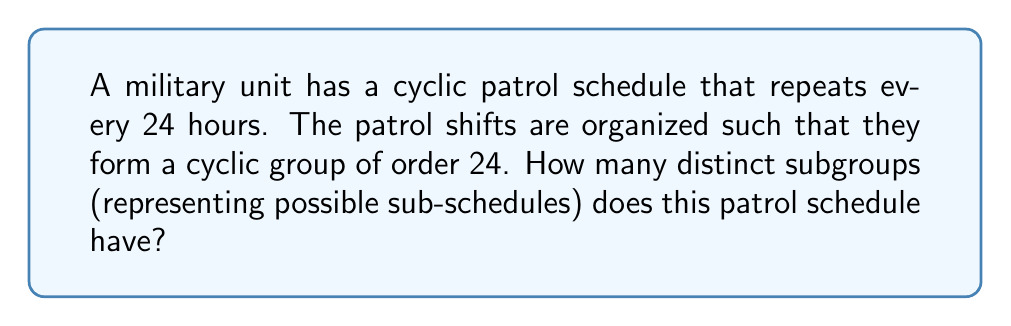Give your solution to this math problem. To solve this problem, we need to understand the structure of cyclic groups and their subgroups. Let's approach this step-by-step:

1) A cyclic group of order 24 is isomorphic to $\mathbb{Z}_{24}$, the group of integers modulo 24.

2) In a cyclic group, the number of subgroups is equal to the number of divisors of the group's order.

3) To find the divisors of 24, let's factor it:
   $24 = 2^3 \times 3$

4) To find the number of divisors, we use the divisor function. For a number $n = p_1^{a_1} \times p_2^{a_2} \times ... \times p_k^{a_k}$, where $p_i$ are distinct primes, the number of divisors is given by:

   $d(n) = (a_1 + 1)(a_2 + 1)...(a_k + 1)$

5) In our case:
   $d(24) = (3 + 1)(1 + 1) = 4 \times 2 = 8$

6) Therefore, there are 8 divisors of 24: 1, 2, 3, 4, 6, 8, 12, and 24.

7) Each of these divisors corresponds to a unique subgroup of the cyclic group of order 24.

   - The subgroup of order 1 is the trivial subgroup {0}.
   - The subgroup of order 2 is generated by 12: {0, 12}
   - The subgroup of order 3 is generated by 8: {0, 8, 16}
   - The subgroup of order 4 is generated by 6: {0, 6, 12, 18}
   - The subgroup of order 6 is generated by 4: {0, 4, 8, 12, 16, 20}
   - The subgroup of order 8 is generated by 3: {0, 3, 6, 9, 12, 15, 18, 21}
   - The subgroup of order 12 is generated by 2: {0, 2, 4, 6, 8, 10, 12, 14, 16, 18, 20, 22}
   - The subgroup of order 24 is the entire group.

Thus, there are 8 distinct subgroups in this cyclic group of order 24.
Answer: 8 distinct subgroups 